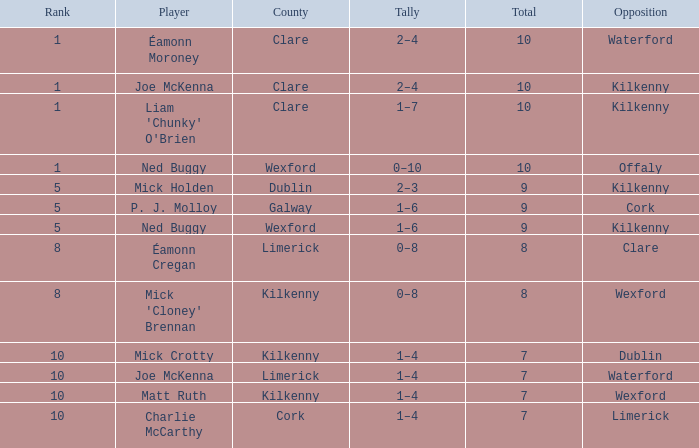What is the aggregate amount for galway county? 9.0. 